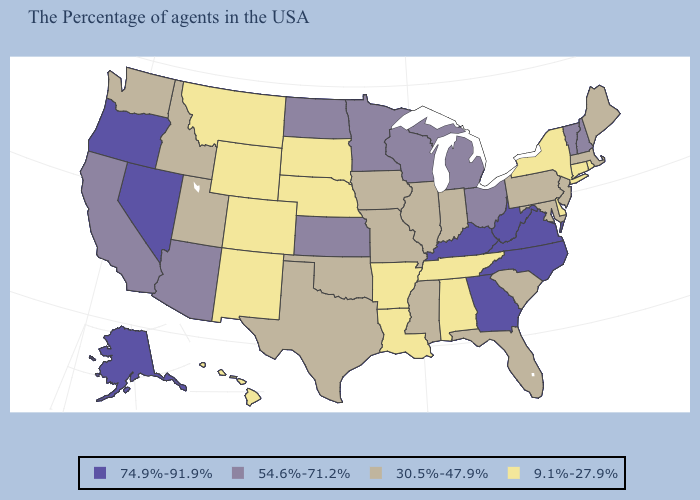Name the states that have a value in the range 9.1%-27.9%?
Write a very short answer. Rhode Island, Connecticut, New York, Delaware, Alabama, Tennessee, Louisiana, Arkansas, Nebraska, South Dakota, Wyoming, Colorado, New Mexico, Montana, Hawaii. Does Maryland have the same value as Delaware?
Write a very short answer. No. Name the states that have a value in the range 74.9%-91.9%?
Keep it brief. Virginia, North Carolina, West Virginia, Georgia, Kentucky, Nevada, Oregon, Alaska. What is the highest value in states that border Delaware?
Quick response, please. 30.5%-47.9%. What is the value of Rhode Island?
Short answer required. 9.1%-27.9%. Does Kansas have the same value as New Hampshire?
Give a very brief answer. Yes. Does Alaska have the highest value in the West?
Quick response, please. Yes. Does the first symbol in the legend represent the smallest category?
Be succinct. No. How many symbols are there in the legend?
Write a very short answer. 4. Does Louisiana have the lowest value in the USA?
Short answer required. Yes. Name the states that have a value in the range 74.9%-91.9%?
Give a very brief answer. Virginia, North Carolina, West Virginia, Georgia, Kentucky, Nevada, Oregon, Alaska. Is the legend a continuous bar?
Short answer required. No. Name the states that have a value in the range 30.5%-47.9%?
Answer briefly. Maine, Massachusetts, New Jersey, Maryland, Pennsylvania, South Carolina, Florida, Indiana, Illinois, Mississippi, Missouri, Iowa, Oklahoma, Texas, Utah, Idaho, Washington. Does Arizona have the same value as Nevada?
Write a very short answer. No. Among the states that border Arizona , does New Mexico have the lowest value?
Write a very short answer. Yes. 